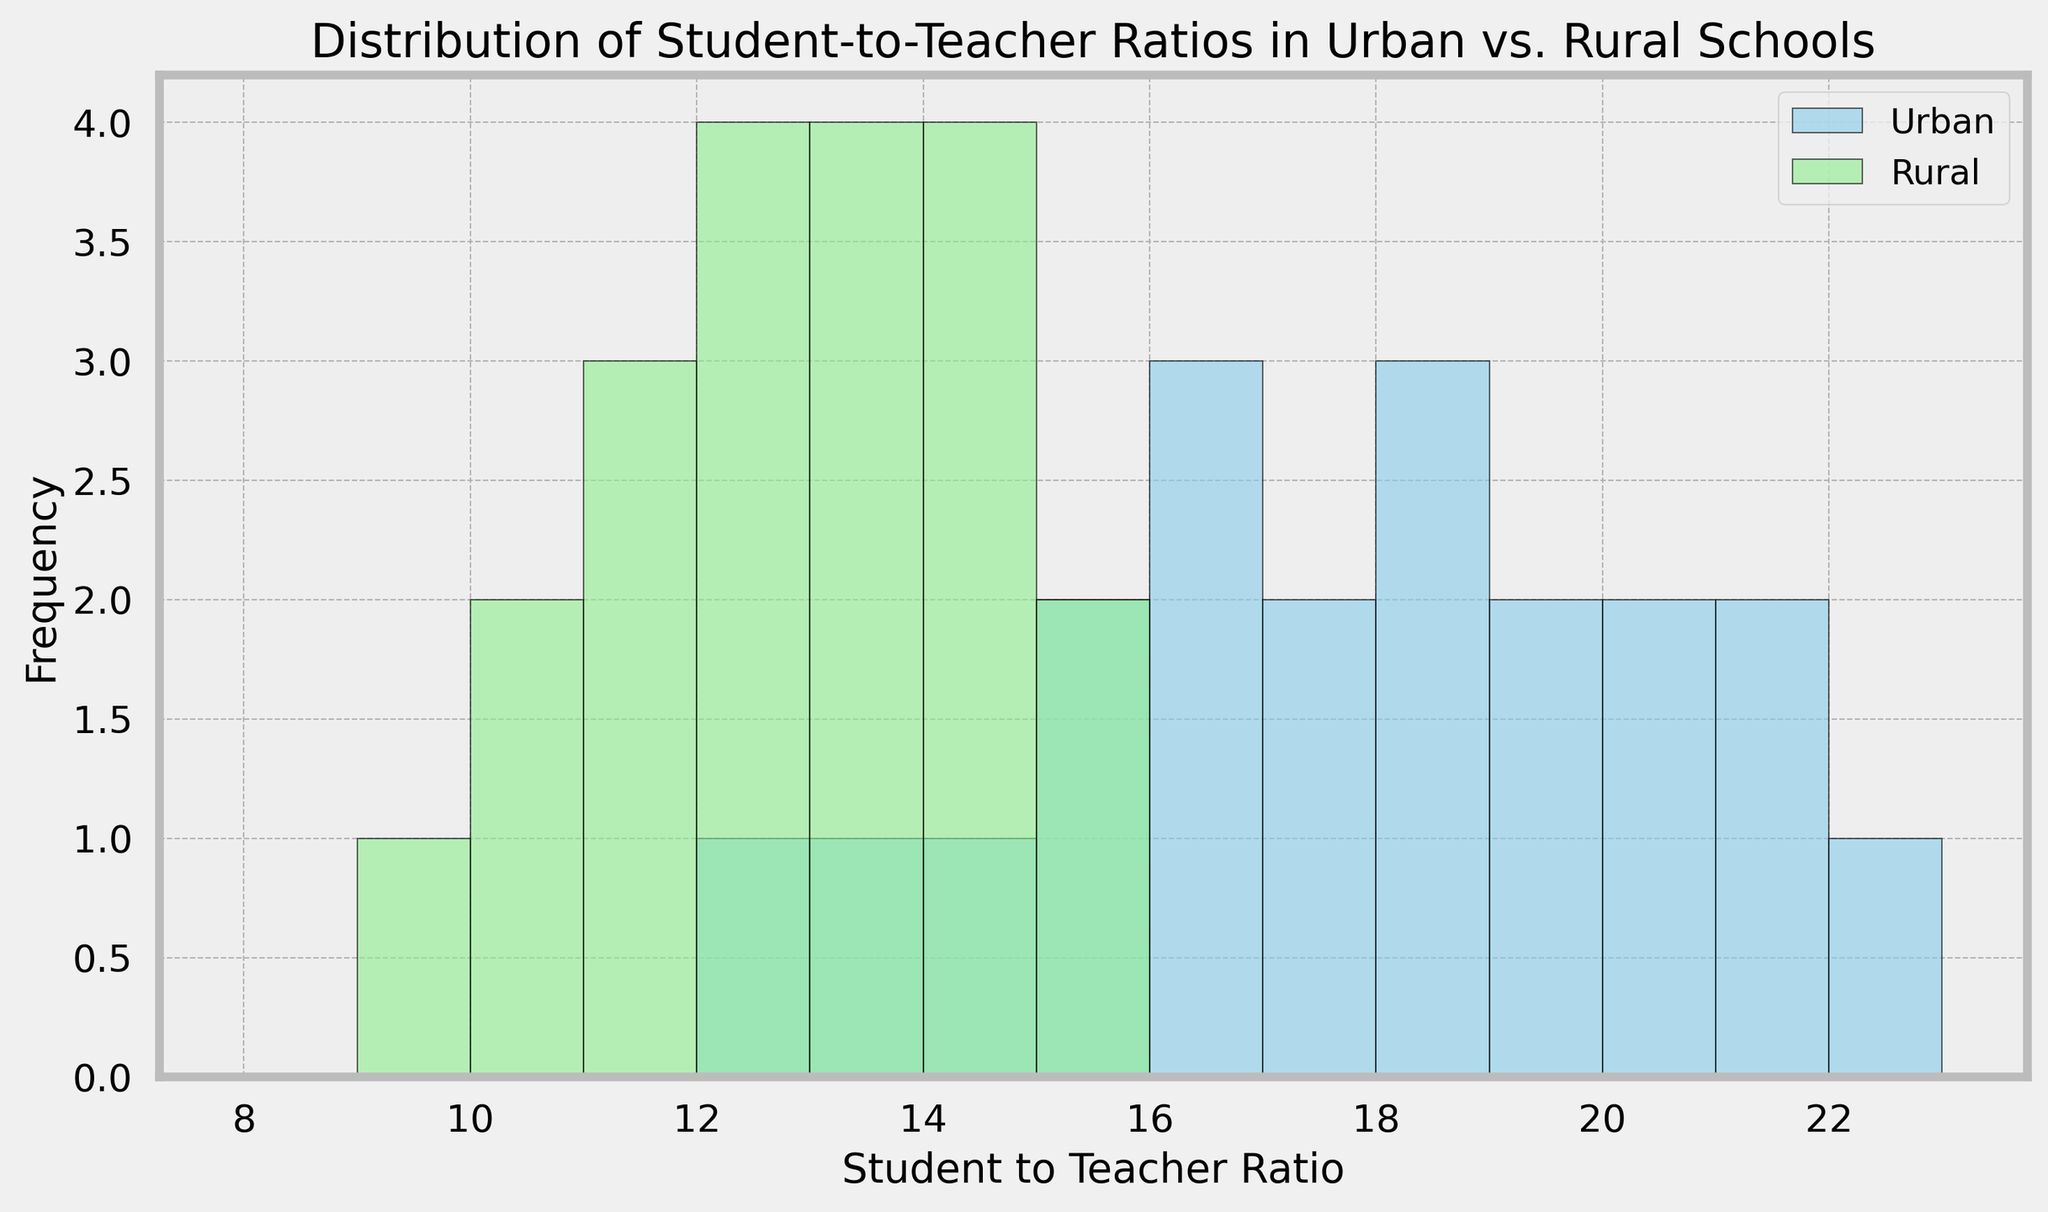Which location has a higher frequency of student-to-teacher ratios between 12 and 14? First, identify the bins between 12 and 14 for both urban and rural locations. Then compare the heights of the bars in these bins. The rural locations show taller bars compared to urban locations between these values.
Answer: Rural What is the most common student-to-teacher ratio range for urban schools? Look at the tallest bar in the histogram for urban schools and determine its corresponding range. The tallest bar is around the bins 18 and 19.
Answer: 18-19 Compare the frequency of student-to-teacher ratios of 15 in urban and rural schools. Which is higher? Identify the bars at the ratio of 15 for both urban and rural schools and compare their heights. The height for urban is taller than rural for the ratio of 15.
Answer: Urban What is the range with the highest frequency of student-to-teacher ratios in rural schools? Observe the tallest bar in the rural histogram and determine the range it represents. The highest bar is seen at the range 12-13.
Answer: 12-13 Which location has a wider spread of student-to-teacher ratios? Examine the length of the x-axis for both urban and rural distributions. Urban data ranges from approximately 12 to 22, while rural data ranges from 9 to 15. Urban has a wider spread.
Answer: Urban How does the spread of data in urban schools compare to rural schools? Compare the minimum and maximum student-to-teacher ratios for both urban and rural schools. Urban spans roughly 11 bins (12 to 22), while rural spans 7 bins (9 to 15). This indicates that urban schools have a wider spread.
Answer: Urban has a wider spread What's the difference in the highest student-to-teacher ratio between urban and rural schools? Identify the highest student-to-teacher ratio for both locations on the histogram. Urban peaks at 22, whereas rural peaks at 15. The difference is 22 - 15 = 7.
Answer: 7 Which location has the lower minimum student-to-teacher ratio? On the x-axis, determine the lowest student-to-teacher ratio for each location. Rural schools have the minimum ratio at 9, while urban has it at 12.
Answer: Rural How many student-to-teacher ratio bins have higher frequencies in rural schools compared to urban schools? Compare the heights of bars for each bin across the histogram. Bins 9, 10, 11, and 14 have higher frequencies in rural schools. There are 4 bins.
Answer: 4 